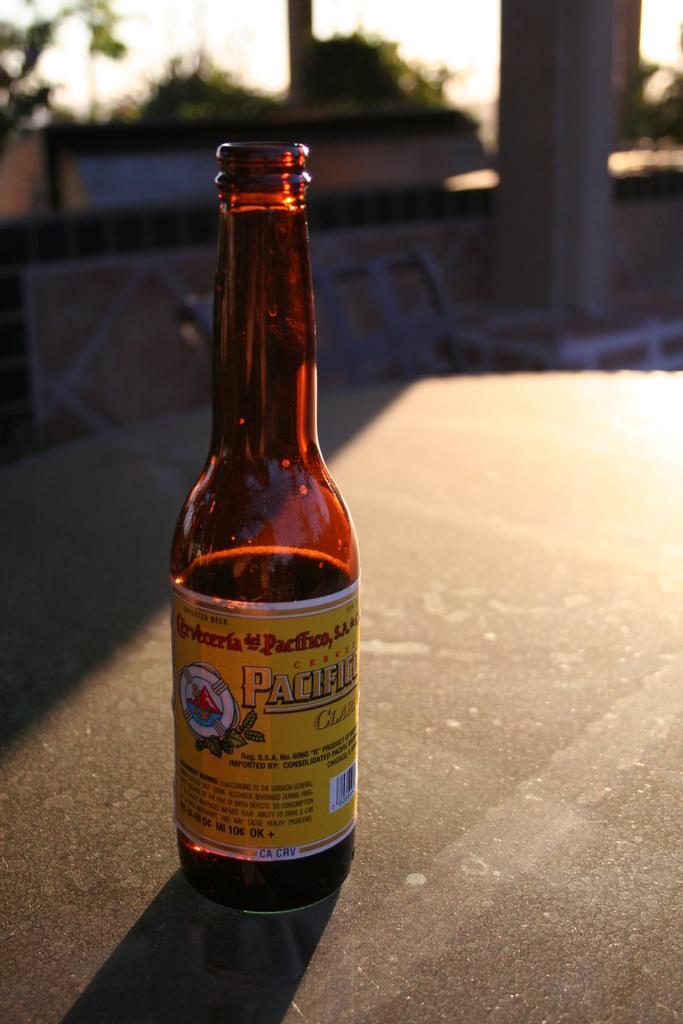<image>
Relay a brief, clear account of the picture shown. A glass bottle on a table that reads pacific. 